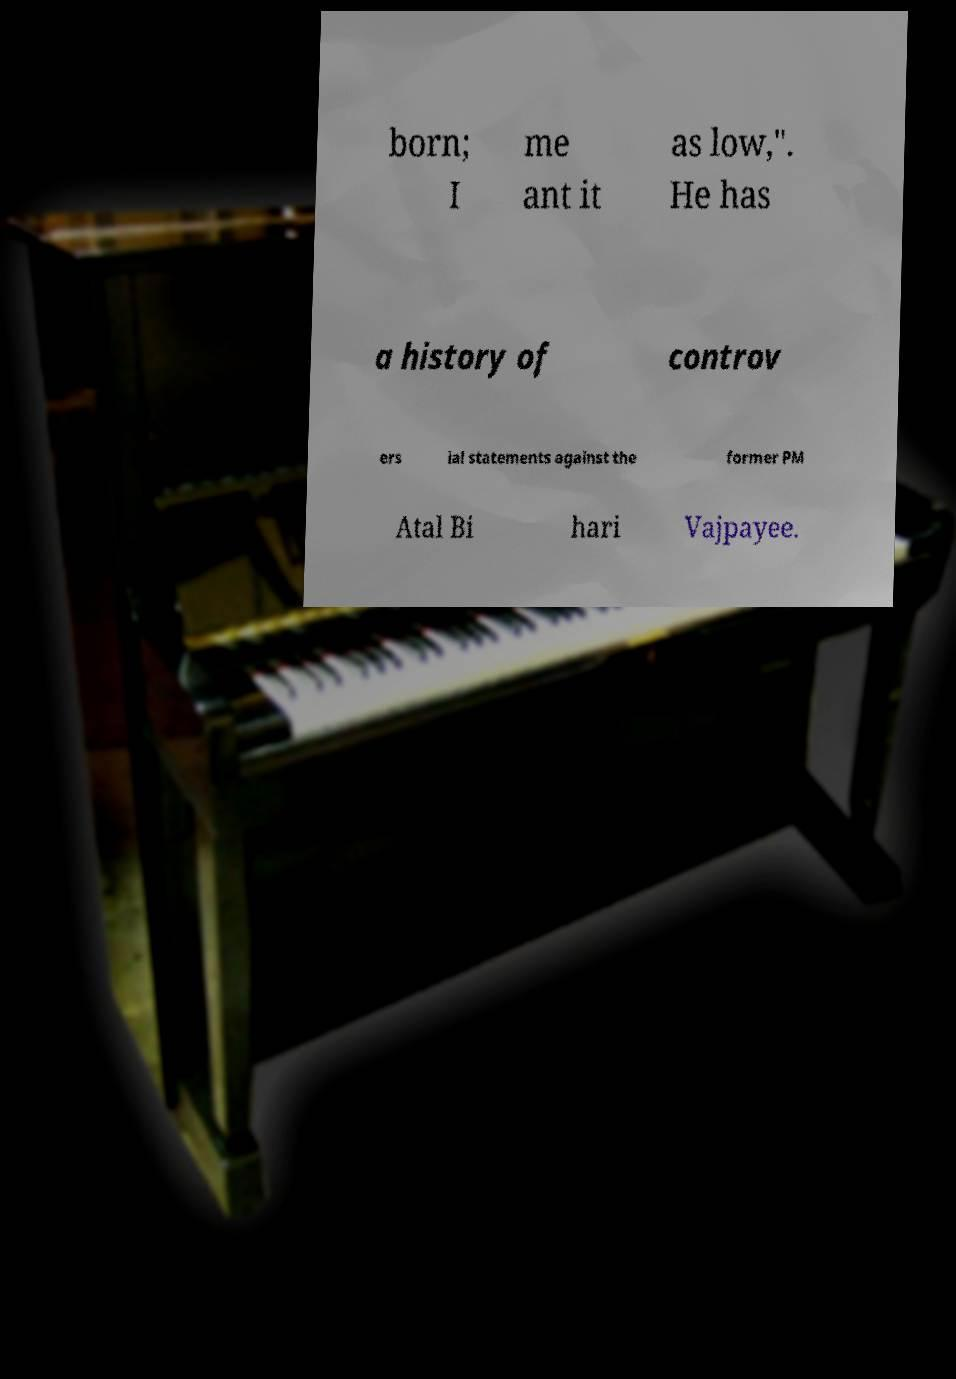Could you extract and type out the text from this image? born; I me ant it as low,". He has a history of controv ers ial statements against the former PM Atal Bi hari Vajpayee. 